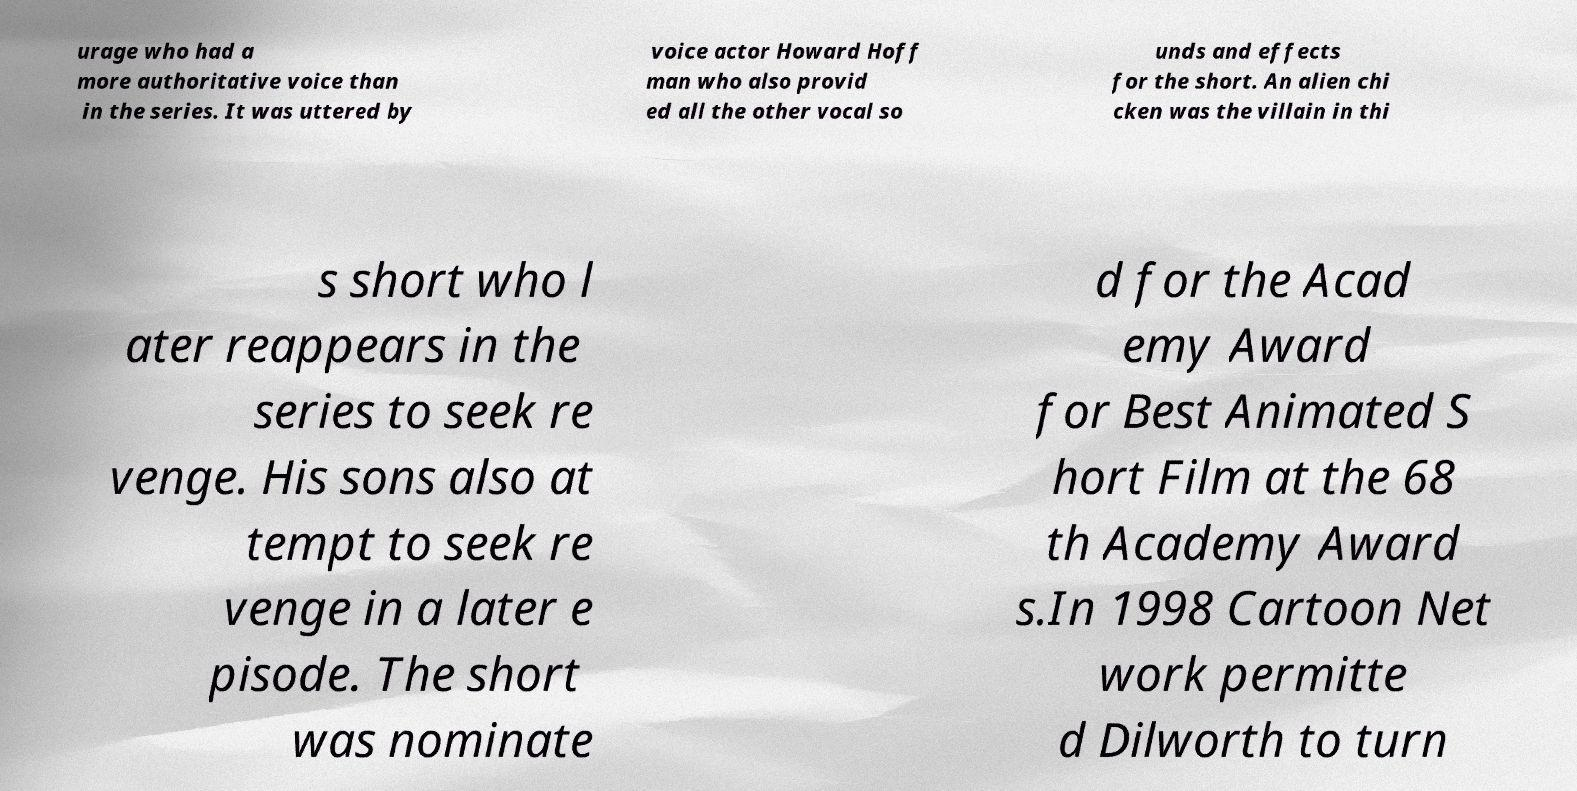Could you extract and type out the text from this image? urage who had a more authoritative voice than in the series. It was uttered by voice actor Howard Hoff man who also provid ed all the other vocal so unds and effects for the short. An alien chi cken was the villain in thi s short who l ater reappears in the series to seek re venge. His sons also at tempt to seek re venge in a later e pisode. The short was nominate d for the Acad emy Award for Best Animated S hort Film at the 68 th Academy Award s.In 1998 Cartoon Net work permitte d Dilworth to turn 